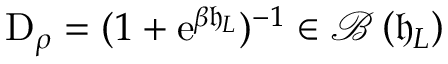<formula> <loc_0><loc_0><loc_500><loc_500>D _ { \rho } = ( 1 + e ^ { \beta \mathfrak { h } _ { L } } ) ^ { - 1 } \in \mathcal { B } \left ( \mathfrak { h } _ { L } \right )</formula> 